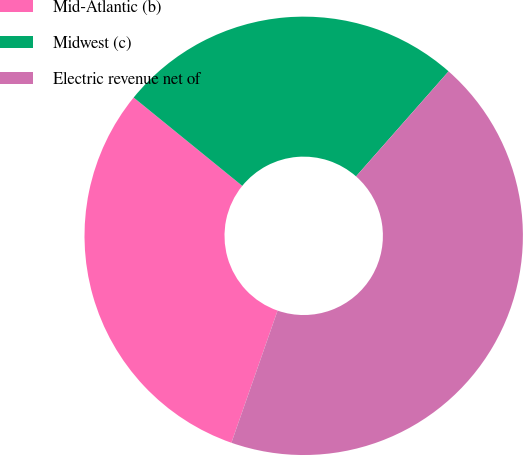Convert chart. <chart><loc_0><loc_0><loc_500><loc_500><pie_chart><fcel>Mid-Atlantic (b)<fcel>Midwest (c)<fcel>Electric revenue net of<nl><fcel>30.52%<fcel>25.63%<fcel>43.86%<nl></chart> 